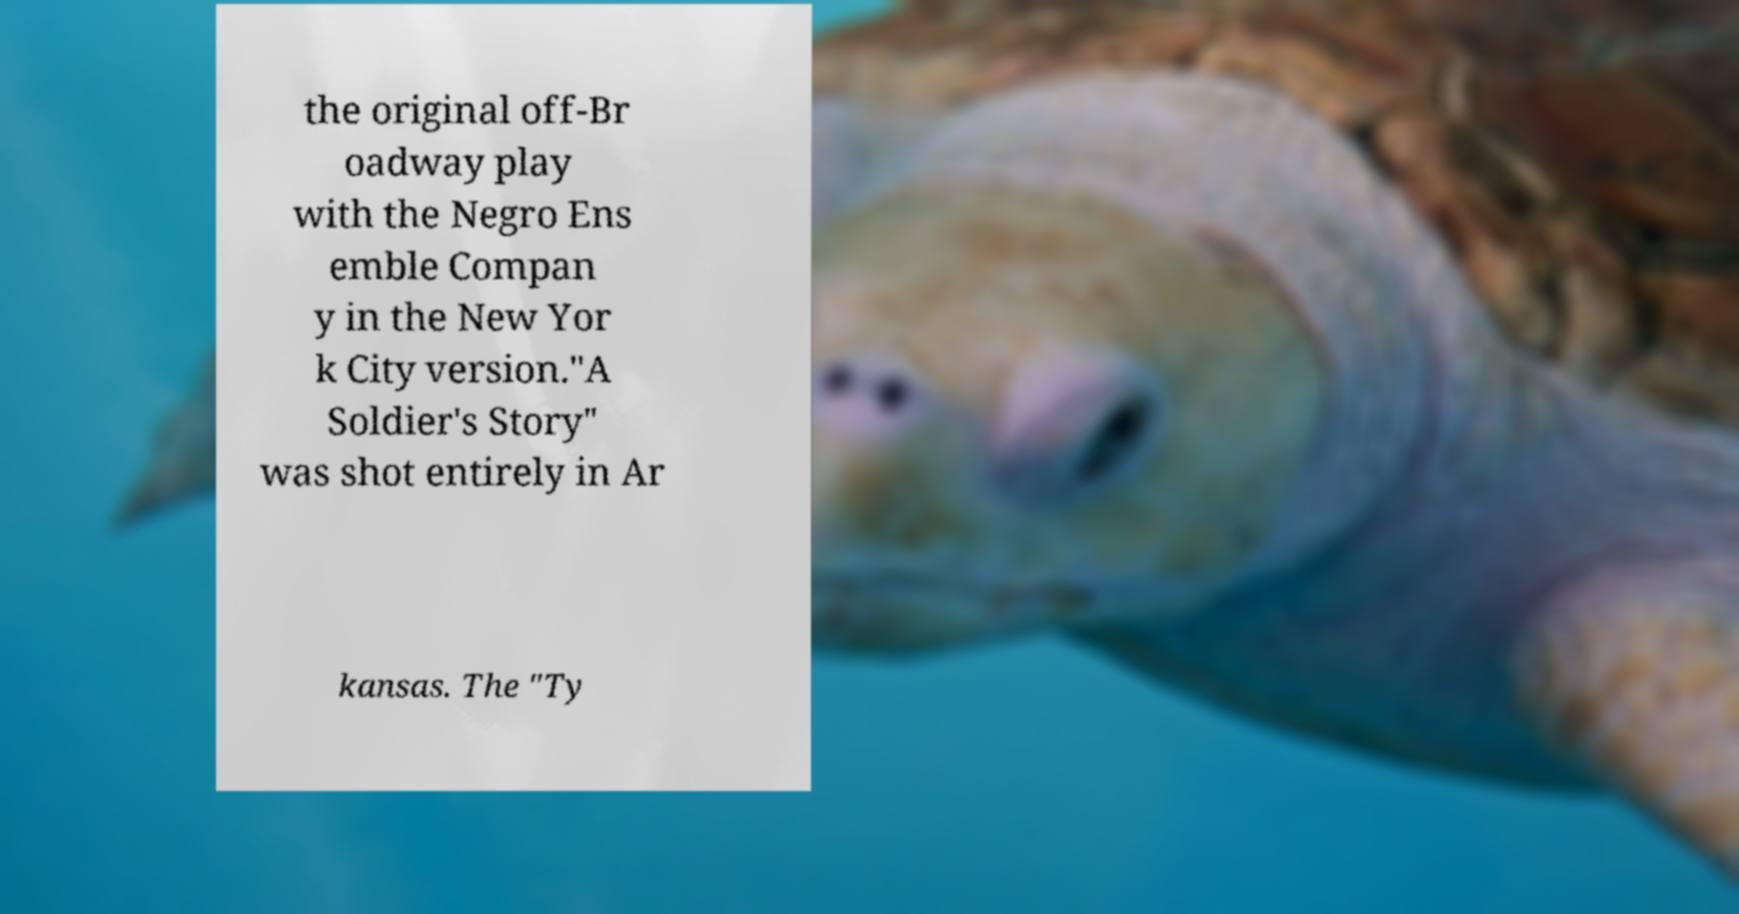I need the written content from this picture converted into text. Can you do that? the original off-Br oadway play with the Negro Ens emble Compan y in the New Yor k City version."A Soldier's Story" was shot entirely in Ar kansas. The "Ty 